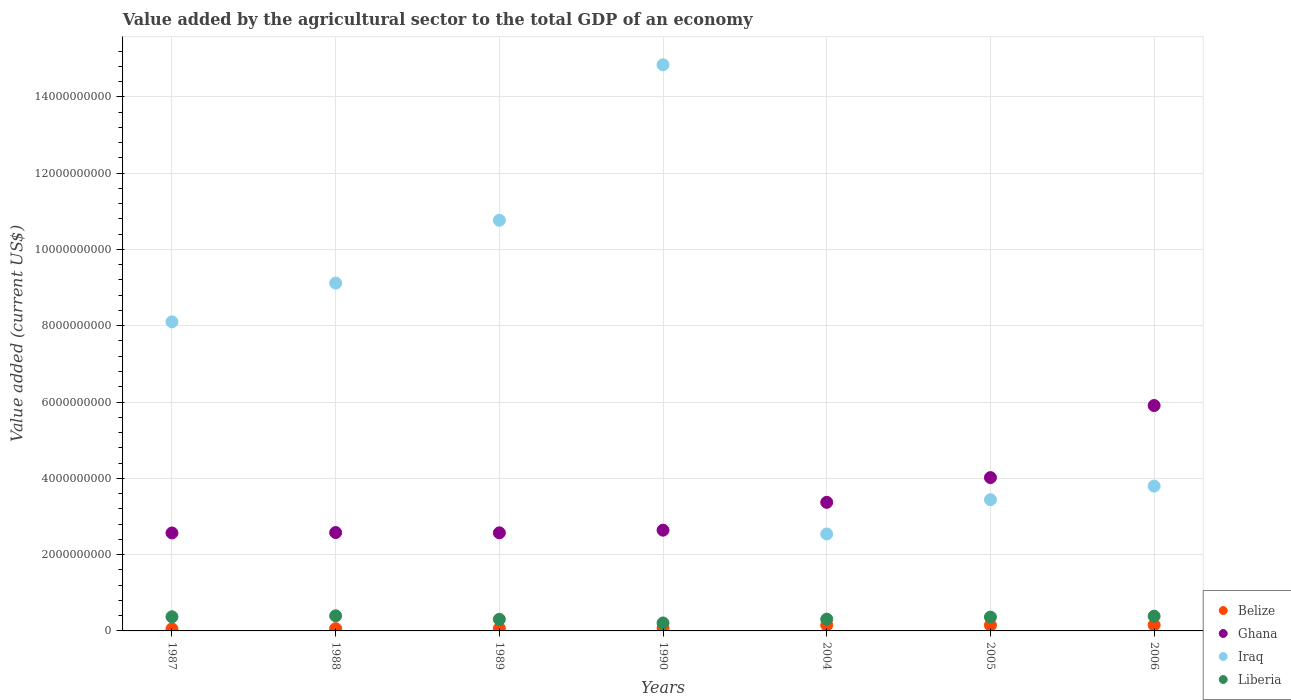What is the value added by the agricultural sector to the total GDP in Liberia in 2006?
Your answer should be compact. 3.85e+08. Across all years, what is the maximum value added by the agricultural sector to the total GDP in Iraq?
Give a very brief answer. 1.48e+1. Across all years, what is the minimum value added by the agricultural sector to the total GDP in Iraq?
Your answer should be compact. 2.54e+09. What is the total value added by the agricultural sector to the total GDP in Iraq in the graph?
Provide a succinct answer. 5.26e+1. What is the difference between the value added by the agricultural sector to the total GDP in Liberia in 1989 and that in 2006?
Provide a succinct answer. -8.10e+07. What is the difference between the value added by the agricultural sector to the total GDP in Belize in 2004 and the value added by the agricultural sector to the total GDP in Ghana in 1989?
Offer a terse response. -2.42e+09. What is the average value added by the agricultural sector to the total GDP in Belize per year?
Offer a very short reply. 1.01e+08. In the year 1987, what is the difference between the value added by the agricultural sector to the total GDP in Belize and value added by the agricultural sector to the total GDP in Ghana?
Make the answer very short. -2.51e+09. In how many years, is the value added by the agricultural sector to the total GDP in Iraq greater than 3200000000 US$?
Your answer should be very brief. 6. What is the ratio of the value added by the agricultural sector to the total GDP in Belize in 1987 to that in 1990?
Make the answer very short. 0.76. Is the value added by the agricultural sector to the total GDP in Ghana in 1987 less than that in 2005?
Make the answer very short. Yes. What is the difference between the highest and the second highest value added by the agricultural sector to the total GDP in Liberia?
Offer a very short reply. 1.02e+07. What is the difference between the highest and the lowest value added by the agricultural sector to the total GDP in Belize?
Give a very brief answer. 1.00e+08. In how many years, is the value added by the agricultural sector to the total GDP in Ghana greater than the average value added by the agricultural sector to the total GDP in Ghana taken over all years?
Your response must be concise. 2. Is the sum of the value added by the agricultural sector to the total GDP in Iraq in 1988 and 1990 greater than the maximum value added by the agricultural sector to the total GDP in Liberia across all years?
Your answer should be very brief. Yes. Is it the case that in every year, the sum of the value added by the agricultural sector to the total GDP in Belize and value added by the agricultural sector to the total GDP in Liberia  is greater than the value added by the agricultural sector to the total GDP in Ghana?
Give a very brief answer. No. Is the value added by the agricultural sector to the total GDP in Liberia strictly greater than the value added by the agricultural sector to the total GDP in Ghana over the years?
Offer a terse response. No. How many dotlines are there?
Make the answer very short. 4. How many years are there in the graph?
Ensure brevity in your answer.  7. What is the difference between two consecutive major ticks on the Y-axis?
Offer a very short reply. 2.00e+09. Are the values on the major ticks of Y-axis written in scientific E-notation?
Keep it short and to the point. No. Does the graph contain any zero values?
Offer a very short reply. No. Does the graph contain grids?
Keep it short and to the point. Yes. What is the title of the graph?
Your response must be concise. Value added by the agricultural sector to the total GDP of an economy. What is the label or title of the Y-axis?
Provide a short and direct response. Value added (current US$). What is the Value added (current US$) in Belize in 1987?
Make the answer very short. 5.45e+07. What is the Value added (current US$) of Ghana in 1987?
Keep it short and to the point. 2.57e+09. What is the Value added (current US$) of Iraq in 1987?
Provide a short and direct response. 8.10e+09. What is the Value added (current US$) of Liberia in 1987?
Offer a terse response. 3.71e+08. What is the Value added (current US$) in Belize in 1988?
Your answer should be very brief. 5.92e+07. What is the Value added (current US$) of Ghana in 1988?
Provide a short and direct response. 2.58e+09. What is the Value added (current US$) in Iraq in 1988?
Your answer should be compact. 9.12e+09. What is the Value added (current US$) of Liberia in 1988?
Provide a succinct answer. 3.96e+08. What is the Value added (current US$) of Belize in 1989?
Make the answer very short. 6.56e+07. What is the Value added (current US$) in Ghana in 1989?
Keep it short and to the point. 2.57e+09. What is the Value added (current US$) in Iraq in 1989?
Your response must be concise. 1.08e+1. What is the Value added (current US$) of Liberia in 1989?
Your response must be concise. 3.04e+08. What is the Value added (current US$) of Belize in 1990?
Your answer should be very brief. 7.18e+07. What is the Value added (current US$) in Ghana in 1990?
Offer a terse response. 2.64e+09. What is the Value added (current US$) of Iraq in 1990?
Provide a short and direct response. 1.48e+1. What is the Value added (current US$) in Liberia in 1990?
Offer a very short reply. 2.09e+08. What is the Value added (current US$) in Belize in 2004?
Your response must be concise. 1.52e+08. What is the Value added (current US$) of Ghana in 2004?
Offer a very short reply. 3.37e+09. What is the Value added (current US$) in Iraq in 2004?
Give a very brief answer. 2.54e+09. What is the Value added (current US$) of Liberia in 2004?
Make the answer very short. 3.09e+08. What is the Value added (current US$) in Belize in 2005?
Make the answer very short. 1.48e+08. What is the Value added (current US$) in Ghana in 2005?
Provide a succinct answer. 4.02e+09. What is the Value added (current US$) in Iraq in 2005?
Make the answer very short. 3.44e+09. What is the Value added (current US$) of Liberia in 2005?
Ensure brevity in your answer.  3.63e+08. What is the Value added (current US$) in Belize in 2006?
Provide a succinct answer. 1.55e+08. What is the Value added (current US$) in Ghana in 2006?
Make the answer very short. 5.91e+09. What is the Value added (current US$) of Iraq in 2006?
Offer a terse response. 3.80e+09. What is the Value added (current US$) in Liberia in 2006?
Provide a short and direct response. 3.85e+08. Across all years, what is the maximum Value added (current US$) of Belize?
Ensure brevity in your answer.  1.55e+08. Across all years, what is the maximum Value added (current US$) of Ghana?
Make the answer very short. 5.91e+09. Across all years, what is the maximum Value added (current US$) of Iraq?
Ensure brevity in your answer.  1.48e+1. Across all years, what is the maximum Value added (current US$) of Liberia?
Ensure brevity in your answer.  3.96e+08. Across all years, what is the minimum Value added (current US$) of Belize?
Offer a terse response. 5.45e+07. Across all years, what is the minimum Value added (current US$) of Ghana?
Your response must be concise. 2.57e+09. Across all years, what is the minimum Value added (current US$) in Iraq?
Make the answer very short. 2.54e+09. Across all years, what is the minimum Value added (current US$) of Liberia?
Keep it short and to the point. 2.09e+08. What is the total Value added (current US$) of Belize in the graph?
Make the answer very short. 7.06e+08. What is the total Value added (current US$) of Ghana in the graph?
Offer a terse response. 2.37e+1. What is the total Value added (current US$) of Iraq in the graph?
Offer a terse response. 5.26e+1. What is the total Value added (current US$) in Liberia in the graph?
Offer a very short reply. 2.34e+09. What is the difference between the Value added (current US$) of Belize in 1987 and that in 1988?
Your answer should be compact. -4.70e+06. What is the difference between the Value added (current US$) of Ghana in 1987 and that in 1988?
Offer a very short reply. -1.09e+07. What is the difference between the Value added (current US$) of Iraq in 1987 and that in 1988?
Your response must be concise. -1.02e+09. What is the difference between the Value added (current US$) in Liberia in 1987 and that in 1988?
Offer a very short reply. -2.48e+07. What is the difference between the Value added (current US$) of Belize in 1987 and that in 1989?
Your answer should be compact. -1.12e+07. What is the difference between the Value added (current US$) of Ghana in 1987 and that in 1989?
Keep it short and to the point. -3.77e+06. What is the difference between the Value added (current US$) of Iraq in 1987 and that in 1989?
Offer a terse response. -2.66e+09. What is the difference between the Value added (current US$) in Liberia in 1987 and that in 1989?
Provide a short and direct response. 6.64e+07. What is the difference between the Value added (current US$) of Belize in 1987 and that in 1990?
Your response must be concise. -1.72e+07. What is the difference between the Value added (current US$) of Ghana in 1987 and that in 1990?
Your answer should be very brief. -7.33e+07. What is the difference between the Value added (current US$) of Iraq in 1987 and that in 1990?
Your answer should be compact. -6.74e+09. What is the difference between the Value added (current US$) of Liberia in 1987 and that in 1990?
Ensure brevity in your answer.  1.62e+08. What is the difference between the Value added (current US$) of Belize in 1987 and that in 2004?
Your answer should be compact. -9.71e+07. What is the difference between the Value added (current US$) in Ghana in 1987 and that in 2004?
Your answer should be very brief. -8.03e+08. What is the difference between the Value added (current US$) in Iraq in 1987 and that in 2004?
Provide a succinct answer. 5.56e+09. What is the difference between the Value added (current US$) in Liberia in 1987 and that in 2004?
Keep it short and to the point. 6.21e+07. What is the difference between the Value added (current US$) in Belize in 1987 and that in 2005?
Offer a very short reply. -9.38e+07. What is the difference between the Value added (current US$) in Ghana in 1987 and that in 2005?
Make the answer very short. -1.45e+09. What is the difference between the Value added (current US$) in Iraq in 1987 and that in 2005?
Offer a very short reply. 4.66e+09. What is the difference between the Value added (current US$) of Liberia in 1987 and that in 2005?
Make the answer very short. 7.72e+06. What is the difference between the Value added (current US$) of Belize in 1987 and that in 2006?
Your answer should be compact. -1.00e+08. What is the difference between the Value added (current US$) in Ghana in 1987 and that in 2006?
Provide a succinct answer. -3.34e+09. What is the difference between the Value added (current US$) in Iraq in 1987 and that in 2006?
Your response must be concise. 4.31e+09. What is the difference between the Value added (current US$) in Liberia in 1987 and that in 2006?
Give a very brief answer. -1.46e+07. What is the difference between the Value added (current US$) of Belize in 1988 and that in 1989?
Provide a short and direct response. -6.45e+06. What is the difference between the Value added (current US$) of Ghana in 1988 and that in 1989?
Offer a terse response. 7.15e+06. What is the difference between the Value added (current US$) in Iraq in 1988 and that in 1989?
Offer a terse response. -1.65e+09. What is the difference between the Value added (current US$) of Liberia in 1988 and that in 1989?
Offer a very short reply. 9.12e+07. What is the difference between the Value added (current US$) of Belize in 1988 and that in 1990?
Your answer should be compact. -1.26e+07. What is the difference between the Value added (current US$) in Ghana in 1988 and that in 1990?
Keep it short and to the point. -6.23e+07. What is the difference between the Value added (current US$) in Iraq in 1988 and that in 1990?
Your response must be concise. -5.72e+09. What is the difference between the Value added (current US$) of Liberia in 1988 and that in 1990?
Provide a short and direct response. 1.87e+08. What is the difference between the Value added (current US$) of Belize in 1988 and that in 2004?
Ensure brevity in your answer.  -9.24e+07. What is the difference between the Value added (current US$) in Ghana in 1988 and that in 2004?
Ensure brevity in your answer.  -7.92e+08. What is the difference between the Value added (current US$) in Iraq in 1988 and that in 2004?
Offer a very short reply. 6.58e+09. What is the difference between the Value added (current US$) in Liberia in 1988 and that in 2004?
Give a very brief answer. 8.69e+07. What is the difference between the Value added (current US$) of Belize in 1988 and that in 2005?
Provide a succinct answer. -8.91e+07. What is the difference between the Value added (current US$) in Ghana in 1988 and that in 2005?
Give a very brief answer. -1.44e+09. What is the difference between the Value added (current US$) in Iraq in 1988 and that in 2005?
Provide a short and direct response. 5.68e+09. What is the difference between the Value added (current US$) of Liberia in 1988 and that in 2005?
Offer a very short reply. 3.25e+07. What is the difference between the Value added (current US$) in Belize in 1988 and that in 2006?
Provide a short and direct response. -9.57e+07. What is the difference between the Value added (current US$) in Ghana in 1988 and that in 2006?
Offer a very short reply. -3.33e+09. What is the difference between the Value added (current US$) of Iraq in 1988 and that in 2006?
Provide a short and direct response. 5.32e+09. What is the difference between the Value added (current US$) in Liberia in 1988 and that in 2006?
Your response must be concise. 1.02e+07. What is the difference between the Value added (current US$) in Belize in 1989 and that in 1990?
Make the answer very short. -6.10e+06. What is the difference between the Value added (current US$) in Ghana in 1989 and that in 1990?
Give a very brief answer. -6.95e+07. What is the difference between the Value added (current US$) in Iraq in 1989 and that in 1990?
Give a very brief answer. -4.08e+09. What is the difference between the Value added (current US$) in Liberia in 1989 and that in 1990?
Your answer should be very brief. 9.55e+07. What is the difference between the Value added (current US$) of Belize in 1989 and that in 2004?
Ensure brevity in your answer.  -8.60e+07. What is the difference between the Value added (current US$) in Ghana in 1989 and that in 2004?
Provide a short and direct response. -7.99e+08. What is the difference between the Value added (current US$) of Iraq in 1989 and that in 2004?
Keep it short and to the point. 8.22e+09. What is the difference between the Value added (current US$) of Liberia in 1989 and that in 2004?
Give a very brief answer. -4.28e+06. What is the difference between the Value added (current US$) of Belize in 1989 and that in 2005?
Keep it short and to the point. -8.26e+07. What is the difference between the Value added (current US$) of Ghana in 1989 and that in 2005?
Offer a terse response. -1.45e+09. What is the difference between the Value added (current US$) of Iraq in 1989 and that in 2005?
Your answer should be very brief. 7.32e+09. What is the difference between the Value added (current US$) of Liberia in 1989 and that in 2005?
Offer a terse response. -5.87e+07. What is the difference between the Value added (current US$) of Belize in 1989 and that in 2006?
Provide a short and direct response. -8.93e+07. What is the difference between the Value added (current US$) of Ghana in 1989 and that in 2006?
Your answer should be compact. -3.34e+09. What is the difference between the Value added (current US$) in Iraq in 1989 and that in 2006?
Provide a succinct answer. 6.97e+09. What is the difference between the Value added (current US$) of Liberia in 1989 and that in 2006?
Provide a succinct answer. -8.10e+07. What is the difference between the Value added (current US$) in Belize in 1990 and that in 2004?
Provide a short and direct response. -7.99e+07. What is the difference between the Value added (current US$) of Ghana in 1990 and that in 2004?
Keep it short and to the point. -7.30e+08. What is the difference between the Value added (current US$) in Iraq in 1990 and that in 2004?
Provide a short and direct response. 1.23e+1. What is the difference between the Value added (current US$) of Liberia in 1990 and that in 2004?
Your answer should be very brief. -9.98e+07. What is the difference between the Value added (current US$) of Belize in 1990 and that in 2005?
Your answer should be compact. -7.65e+07. What is the difference between the Value added (current US$) in Ghana in 1990 and that in 2005?
Provide a short and direct response. -1.38e+09. What is the difference between the Value added (current US$) in Iraq in 1990 and that in 2005?
Keep it short and to the point. 1.14e+1. What is the difference between the Value added (current US$) in Liberia in 1990 and that in 2005?
Your answer should be very brief. -1.54e+08. What is the difference between the Value added (current US$) in Belize in 1990 and that in 2006?
Your answer should be compact. -8.32e+07. What is the difference between the Value added (current US$) of Ghana in 1990 and that in 2006?
Make the answer very short. -3.27e+09. What is the difference between the Value added (current US$) of Iraq in 1990 and that in 2006?
Offer a very short reply. 1.10e+1. What is the difference between the Value added (current US$) in Liberia in 1990 and that in 2006?
Offer a very short reply. -1.76e+08. What is the difference between the Value added (current US$) of Belize in 2004 and that in 2005?
Provide a short and direct response. 3.34e+06. What is the difference between the Value added (current US$) of Ghana in 2004 and that in 2005?
Offer a terse response. -6.49e+08. What is the difference between the Value added (current US$) of Iraq in 2004 and that in 2005?
Make the answer very short. -8.99e+08. What is the difference between the Value added (current US$) of Liberia in 2004 and that in 2005?
Give a very brief answer. -5.44e+07. What is the difference between the Value added (current US$) in Belize in 2004 and that in 2006?
Offer a terse response. -3.29e+06. What is the difference between the Value added (current US$) of Ghana in 2004 and that in 2006?
Give a very brief answer. -2.54e+09. What is the difference between the Value added (current US$) in Iraq in 2004 and that in 2006?
Make the answer very short. -1.25e+09. What is the difference between the Value added (current US$) in Liberia in 2004 and that in 2006?
Offer a terse response. -7.67e+07. What is the difference between the Value added (current US$) of Belize in 2005 and that in 2006?
Your answer should be very brief. -6.64e+06. What is the difference between the Value added (current US$) in Ghana in 2005 and that in 2006?
Keep it short and to the point. -1.89e+09. What is the difference between the Value added (current US$) of Iraq in 2005 and that in 2006?
Make the answer very short. -3.55e+08. What is the difference between the Value added (current US$) in Liberia in 2005 and that in 2006?
Ensure brevity in your answer.  -2.23e+07. What is the difference between the Value added (current US$) of Belize in 1987 and the Value added (current US$) of Ghana in 1988?
Ensure brevity in your answer.  -2.52e+09. What is the difference between the Value added (current US$) of Belize in 1987 and the Value added (current US$) of Iraq in 1988?
Provide a short and direct response. -9.06e+09. What is the difference between the Value added (current US$) of Belize in 1987 and the Value added (current US$) of Liberia in 1988?
Make the answer very short. -3.41e+08. What is the difference between the Value added (current US$) in Ghana in 1987 and the Value added (current US$) in Iraq in 1988?
Your answer should be compact. -6.55e+09. What is the difference between the Value added (current US$) in Ghana in 1987 and the Value added (current US$) in Liberia in 1988?
Your answer should be compact. 2.17e+09. What is the difference between the Value added (current US$) of Iraq in 1987 and the Value added (current US$) of Liberia in 1988?
Your answer should be compact. 7.71e+09. What is the difference between the Value added (current US$) in Belize in 1987 and the Value added (current US$) in Ghana in 1989?
Give a very brief answer. -2.52e+09. What is the difference between the Value added (current US$) in Belize in 1987 and the Value added (current US$) in Iraq in 1989?
Your answer should be compact. -1.07e+1. What is the difference between the Value added (current US$) in Belize in 1987 and the Value added (current US$) in Liberia in 1989?
Offer a very short reply. -2.50e+08. What is the difference between the Value added (current US$) in Ghana in 1987 and the Value added (current US$) in Iraq in 1989?
Ensure brevity in your answer.  -8.20e+09. What is the difference between the Value added (current US$) of Ghana in 1987 and the Value added (current US$) of Liberia in 1989?
Keep it short and to the point. 2.26e+09. What is the difference between the Value added (current US$) of Iraq in 1987 and the Value added (current US$) of Liberia in 1989?
Offer a very short reply. 7.80e+09. What is the difference between the Value added (current US$) in Belize in 1987 and the Value added (current US$) in Ghana in 1990?
Your response must be concise. -2.59e+09. What is the difference between the Value added (current US$) in Belize in 1987 and the Value added (current US$) in Iraq in 1990?
Offer a very short reply. -1.48e+1. What is the difference between the Value added (current US$) in Belize in 1987 and the Value added (current US$) in Liberia in 1990?
Your response must be concise. -1.54e+08. What is the difference between the Value added (current US$) of Ghana in 1987 and the Value added (current US$) of Iraq in 1990?
Make the answer very short. -1.23e+1. What is the difference between the Value added (current US$) of Ghana in 1987 and the Value added (current US$) of Liberia in 1990?
Keep it short and to the point. 2.36e+09. What is the difference between the Value added (current US$) of Iraq in 1987 and the Value added (current US$) of Liberia in 1990?
Provide a succinct answer. 7.89e+09. What is the difference between the Value added (current US$) of Belize in 1987 and the Value added (current US$) of Ghana in 2004?
Ensure brevity in your answer.  -3.32e+09. What is the difference between the Value added (current US$) of Belize in 1987 and the Value added (current US$) of Iraq in 2004?
Your response must be concise. -2.49e+09. What is the difference between the Value added (current US$) of Belize in 1987 and the Value added (current US$) of Liberia in 2004?
Keep it short and to the point. -2.54e+08. What is the difference between the Value added (current US$) in Ghana in 1987 and the Value added (current US$) in Iraq in 2004?
Offer a terse response. 2.64e+07. What is the difference between the Value added (current US$) of Ghana in 1987 and the Value added (current US$) of Liberia in 2004?
Ensure brevity in your answer.  2.26e+09. What is the difference between the Value added (current US$) in Iraq in 1987 and the Value added (current US$) in Liberia in 2004?
Your response must be concise. 7.79e+09. What is the difference between the Value added (current US$) in Belize in 1987 and the Value added (current US$) in Ghana in 2005?
Keep it short and to the point. -3.96e+09. What is the difference between the Value added (current US$) in Belize in 1987 and the Value added (current US$) in Iraq in 2005?
Your answer should be compact. -3.39e+09. What is the difference between the Value added (current US$) in Belize in 1987 and the Value added (current US$) in Liberia in 2005?
Keep it short and to the point. -3.09e+08. What is the difference between the Value added (current US$) of Ghana in 1987 and the Value added (current US$) of Iraq in 2005?
Offer a terse response. -8.72e+08. What is the difference between the Value added (current US$) of Ghana in 1987 and the Value added (current US$) of Liberia in 2005?
Offer a very short reply. 2.20e+09. What is the difference between the Value added (current US$) of Iraq in 1987 and the Value added (current US$) of Liberia in 2005?
Keep it short and to the point. 7.74e+09. What is the difference between the Value added (current US$) of Belize in 1987 and the Value added (current US$) of Ghana in 2006?
Offer a terse response. -5.85e+09. What is the difference between the Value added (current US$) in Belize in 1987 and the Value added (current US$) in Iraq in 2006?
Your answer should be compact. -3.74e+09. What is the difference between the Value added (current US$) of Belize in 1987 and the Value added (current US$) of Liberia in 2006?
Your answer should be compact. -3.31e+08. What is the difference between the Value added (current US$) of Ghana in 1987 and the Value added (current US$) of Iraq in 2006?
Make the answer very short. -1.23e+09. What is the difference between the Value added (current US$) of Ghana in 1987 and the Value added (current US$) of Liberia in 2006?
Offer a terse response. 2.18e+09. What is the difference between the Value added (current US$) of Iraq in 1987 and the Value added (current US$) of Liberia in 2006?
Provide a short and direct response. 7.72e+09. What is the difference between the Value added (current US$) of Belize in 1988 and the Value added (current US$) of Ghana in 1989?
Ensure brevity in your answer.  -2.51e+09. What is the difference between the Value added (current US$) of Belize in 1988 and the Value added (current US$) of Iraq in 1989?
Ensure brevity in your answer.  -1.07e+1. What is the difference between the Value added (current US$) of Belize in 1988 and the Value added (current US$) of Liberia in 1989?
Your answer should be very brief. -2.45e+08. What is the difference between the Value added (current US$) of Ghana in 1988 and the Value added (current US$) of Iraq in 1989?
Offer a very short reply. -8.19e+09. What is the difference between the Value added (current US$) of Ghana in 1988 and the Value added (current US$) of Liberia in 1989?
Your answer should be compact. 2.27e+09. What is the difference between the Value added (current US$) of Iraq in 1988 and the Value added (current US$) of Liberia in 1989?
Provide a short and direct response. 8.81e+09. What is the difference between the Value added (current US$) of Belize in 1988 and the Value added (current US$) of Ghana in 1990?
Provide a short and direct response. -2.58e+09. What is the difference between the Value added (current US$) in Belize in 1988 and the Value added (current US$) in Iraq in 1990?
Provide a succinct answer. -1.48e+1. What is the difference between the Value added (current US$) of Belize in 1988 and the Value added (current US$) of Liberia in 1990?
Your answer should be compact. -1.50e+08. What is the difference between the Value added (current US$) of Ghana in 1988 and the Value added (current US$) of Iraq in 1990?
Keep it short and to the point. -1.23e+1. What is the difference between the Value added (current US$) of Ghana in 1988 and the Value added (current US$) of Liberia in 1990?
Give a very brief answer. 2.37e+09. What is the difference between the Value added (current US$) in Iraq in 1988 and the Value added (current US$) in Liberia in 1990?
Provide a short and direct response. 8.91e+09. What is the difference between the Value added (current US$) of Belize in 1988 and the Value added (current US$) of Ghana in 2004?
Make the answer very short. -3.31e+09. What is the difference between the Value added (current US$) in Belize in 1988 and the Value added (current US$) in Iraq in 2004?
Keep it short and to the point. -2.48e+09. What is the difference between the Value added (current US$) of Belize in 1988 and the Value added (current US$) of Liberia in 2004?
Your answer should be compact. -2.50e+08. What is the difference between the Value added (current US$) of Ghana in 1988 and the Value added (current US$) of Iraq in 2004?
Offer a terse response. 3.74e+07. What is the difference between the Value added (current US$) of Ghana in 1988 and the Value added (current US$) of Liberia in 2004?
Your answer should be very brief. 2.27e+09. What is the difference between the Value added (current US$) of Iraq in 1988 and the Value added (current US$) of Liberia in 2004?
Ensure brevity in your answer.  8.81e+09. What is the difference between the Value added (current US$) in Belize in 1988 and the Value added (current US$) in Ghana in 2005?
Give a very brief answer. -3.96e+09. What is the difference between the Value added (current US$) in Belize in 1988 and the Value added (current US$) in Iraq in 2005?
Your answer should be compact. -3.38e+09. What is the difference between the Value added (current US$) in Belize in 1988 and the Value added (current US$) in Liberia in 2005?
Provide a short and direct response. -3.04e+08. What is the difference between the Value added (current US$) in Ghana in 1988 and the Value added (current US$) in Iraq in 2005?
Your answer should be very brief. -8.62e+08. What is the difference between the Value added (current US$) in Ghana in 1988 and the Value added (current US$) in Liberia in 2005?
Your answer should be very brief. 2.22e+09. What is the difference between the Value added (current US$) of Iraq in 1988 and the Value added (current US$) of Liberia in 2005?
Offer a very short reply. 8.75e+09. What is the difference between the Value added (current US$) in Belize in 1988 and the Value added (current US$) in Ghana in 2006?
Keep it short and to the point. -5.85e+09. What is the difference between the Value added (current US$) in Belize in 1988 and the Value added (current US$) in Iraq in 2006?
Your answer should be compact. -3.74e+09. What is the difference between the Value added (current US$) of Belize in 1988 and the Value added (current US$) of Liberia in 2006?
Ensure brevity in your answer.  -3.26e+08. What is the difference between the Value added (current US$) in Ghana in 1988 and the Value added (current US$) in Iraq in 2006?
Offer a very short reply. -1.22e+09. What is the difference between the Value added (current US$) in Ghana in 1988 and the Value added (current US$) in Liberia in 2006?
Make the answer very short. 2.19e+09. What is the difference between the Value added (current US$) of Iraq in 1988 and the Value added (current US$) of Liberia in 2006?
Offer a very short reply. 8.73e+09. What is the difference between the Value added (current US$) in Belize in 1989 and the Value added (current US$) in Ghana in 1990?
Keep it short and to the point. -2.58e+09. What is the difference between the Value added (current US$) of Belize in 1989 and the Value added (current US$) of Iraq in 1990?
Provide a short and direct response. -1.48e+1. What is the difference between the Value added (current US$) in Belize in 1989 and the Value added (current US$) in Liberia in 1990?
Your response must be concise. -1.43e+08. What is the difference between the Value added (current US$) of Ghana in 1989 and the Value added (current US$) of Iraq in 1990?
Provide a succinct answer. -1.23e+1. What is the difference between the Value added (current US$) in Ghana in 1989 and the Value added (current US$) in Liberia in 1990?
Make the answer very short. 2.36e+09. What is the difference between the Value added (current US$) of Iraq in 1989 and the Value added (current US$) of Liberia in 1990?
Give a very brief answer. 1.06e+1. What is the difference between the Value added (current US$) in Belize in 1989 and the Value added (current US$) in Ghana in 2004?
Provide a short and direct response. -3.31e+09. What is the difference between the Value added (current US$) in Belize in 1989 and the Value added (current US$) in Iraq in 2004?
Your response must be concise. -2.48e+09. What is the difference between the Value added (current US$) in Belize in 1989 and the Value added (current US$) in Liberia in 2004?
Give a very brief answer. -2.43e+08. What is the difference between the Value added (current US$) in Ghana in 1989 and the Value added (current US$) in Iraq in 2004?
Make the answer very short. 3.02e+07. What is the difference between the Value added (current US$) of Ghana in 1989 and the Value added (current US$) of Liberia in 2004?
Ensure brevity in your answer.  2.26e+09. What is the difference between the Value added (current US$) in Iraq in 1989 and the Value added (current US$) in Liberia in 2004?
Ensure brevity in your answer.  1.05e+1. What is the difference between the Value added (current US$) of Belize in 1989 and the Value added (current US$) of Ghana in 2005?
Keep it short and to the point. -3.95e+09. What is the difference between the Value added (current US$) of Belize in 1989 and the Value added (current US$) of Iraq in 2005?
Keep it short and to the point. -3.37e+09. What is the difference between the Value added (current US$) of Belize in 1989 and the Value added (current US$) of Liberia in 2005?
Make the answer very short. -2.98e+08. What is the difference between the Value added (current US$) of Ghana in 1989 and the Value added (current US$) of Iraq in 2005?
Keep it short and to the point. -8.69e+08. What is the difference between the Value added (current US$) in Ghana in 1989 and the Value added (current US$) in Liberia in 2005?
Provide a succinct answer. 2.21e+09. What is the difference between the Value added (current US$) of Iraq in 1989 and the Value added (current US$) of Liberia in 2005?
Offer a terse response. 1.04e+1. What is the difference between the Value added (current US$) of Belize in 1989 and the Value added (current US$) of Ghana in 2006?
Offer a terse response. -5.84e+09. What is the difference between the Value added (current US$) in Belize in 1989 and the Value added (current US$) in Iraq in 2006?
Your response must be concise. -3.73e+09. What is the difference between the Value added (current US$) in Belize in 1989 and the Value added (current US$) in Liberia in 2006?
Your answer should be very brief. -3.20e+08. What is the difference between the Value added (current US$) in Ghana in 1989 and the Value added (current US$) in Iraq in 2006?
Offer a terse response. -1.22e+09. What is the difference between the Value added (current US$) of Ghana in 1989 and the Value added (current US$) of Liberia in 2006?
Keep it short and to the point. 2.19e+09. What is the difference between the Value added (current US$) in Iraq in 1989 and the Value added (current US$) in Liberia in 2006?
Offer a terse response. 1.04e+1. What is the difference between the Value added (current US$) of Belize in 1990 and the Value added (current US$) of Ghana in 2004?
Offer a very short reply. -3.30e+09. What is the difference between the Value added (current US$) of Belize in 1990 and the Value added (current US$) of Iraq in 2004?
Your response must be concise. -2.47e+09. What is the difference between the Value added (current US$) of Belize in 1990 and the Value added (current US$) of Liberia in 2004?
Ensure brevity in your answer.  -2.37e+08. What is the difference between the Value added (current US$) of Ghana in 1990 and the Value added (current US$) of Iraq in 2004?
Your answer should be very brief. 9.97e+07. What is the difference between the Value added (current US$) in Ghana in 1990 and the Value added (current US$) in Liberia in 2004?
Make the answer very short. 2.33e+09. What is the difference between the Value added (current US$) in Iraq in 1990 and the Value added (current US$) in Liberia in 2004?
Ensure brevity in your answer.  1.45e+1. What is the difference between the Value added (current US$) in Belize in 1990 and the Value added (current US$) in Ghana in 2005?
Offer a terse response. -3.95e+09. What is the difference between the Value added (current US$) in Belize in 1990 and the Value added (current US$) in Iraq in 2005?
Your answer should be compact. -3.37e+09. What is the difference between the Value added (current US$) in Belize in 1990 and the Value added (current US$) in Liberia in 2005?
Keep it short and to the point. -2.91e+08. What is the difference between the Value added (current US$) of Ghana in 1990 and the Value added (current US$) of Iraq in 2005?
Ensure brevity in your answer.  -7.99e+08. What is the difference between the Value added (current US$) of Ghana in 1990 and the Value added (current US$) of Liberia in 2005?
Your answer should be compact. 2.28e+09. What is the difference between the Value added (current US$) in Iraq in 1990 and the Value added (current US$) in Liberia in 2005?
Offer a very short reply. 1.45e+1. What is the difference between the Value added (current US$) of Belize in 1990 and the Value added (current US$) of Ghana in 2006?
Your answer should be compact. -5.84e+09. What is the difference between the Value added (current US$) of Belize in 1990 and the Value added (current US$) of Iraq in 2006?
Your response must be concise. -3.72e+09. What is the difference between the Value added (current US$) of Belize in 1990 and the Value added (current US$) of Liberia in 2006?
Offer a terse response. -3.14e+08. What is the difference between the Value added (current US$) in Ghana in 1990 and the Value added (current US$) in Iraq in 2006?
Your response must be concise. -1.15e+09. What is the difference between the Value added (current US$) in Ghana in 1990 and the Value added (current US$) in Liberia in 2006?
Your answer should be compact. 2.26e+09. What is the difference between the Value added (current US$) in Iraq in 1990 and the Value added (current US$) in Liberia in 2006?
Ensure brevity in your answer.  1.45e+1. What is the difference between the Value added (current US$) of Belize in 2004 and the Value added (current US$) of Ghana in 2005?
Provide a succinct answer. -3.87e+09. What is the difference between the Value added (current US$) of Belize in 2004 and the Value added (current US$) of Iraq in 2005?
Give a very brief answer. -3.29e+09. What is the difference between the Value added (current US$) of Belize in 2004 and the Value added (current US$) of Liberia in 2005?
Your answer should be compact. -2.12e+08. What is the difference between the Value added (current US$) in Ghana in 2004 and the Value added (current US$) in Iraq in 2005?
Offer a very short reply. -6.96e+07. What is the difference between the Value added (current US$) in Ghana in 2004 and the Value added (current US$) in Liberia in 2005?
Provide a succinct answer. 3.01e+09. What is the difference between the Value added (current US$) in Iraq in 2004 and the Value added (current US$) in Liberia in 2005?
Ensure brevity in your answer.  2.18e+09. What is the difference between the Value added (current US$) in Belize in 2004 and the Value added (current US$) in Ghana in 2006?
Your answer should be very brief. -5.76e+09. What is the difference between the Value added (current US$) in Belize in 2004 and the Value added (current US$) in Iraq in 2006?
Make the answer very short. -3.64e+09. What is the difference between the Value added (current US$) of Belize in 2004 and the Value added (current US$) of Liberia in 2006?
Offer a terse response. -2.34e+08. What is the difference between the Value added (current US$) in Ghana in 2004 and the Value added (current US$) in Iraq in 2006?
Provide a succinct answer. -4.24e+08. What is the difference between the Value added (current US$) in Ghana in 2004 and the Value added (current US$) in Liberia in 2006?
Give a very brief answer. 2.99e+09. What is the difference between the Value added (current US$) of Iraq in 2004 and the Value added (current US$) of Liberia in 2006?
Give a very brief answer. 2.16e+09. What is the difference between the Value added (current US$) in Belize in 2005 and the Value added (current US$) in Ghana in 2006?
Ensure brevity in your answer.  -5.76e+09. What is the difference between the Value added (current US$) of Belize in 2005 and the Value added (current US$) of Iraq in 2006?
Ensure brevity in your answer.  -3.65e+09. What is the difference between the Value added (current US$) of Belize in 2005 and the Value added (current US$) of Liberia in 2006?
Your answer should be compact. -2.37e+08. What is the difference between the Value added (current US$) of Ghana in 2005 and the Value added (current US$) of Iraq in 2006?
Give a very brief answer. 2.24e+08. What is the difference between the Value added (current US$) of Ghana in 2005 and the Value added (current US$) of Liberia in 2006?
Give a very brief answer. 3.63e+09. What is the difference between the Value added (current US$) in Iraq in 2005 and the Value added (current US$) in Liberia in 2006?
Make the answer very short. 3.05e+09. What is the average Value added (current US$) in Belize per year?
Your response must be concise. 1.01e+08. What is the average Value added (current US$) of Ghana per year?
Give a very brief answer. 3.38e+09. What is the average Value added (current US$) of Iraq per year?
Offer a terse response. 7.51e+09. What is the average Value added (current US$) of Liberia per year?
Your answer should be compact. 3.34e+08. In the year 1987, what is the difference between the Value added (current US$) of Belize and Value added (current US$) of Ghana?
Provide a succinct answer. -2.51e+09. In the year 1987, what is the difference between the Value added (current US$) of Belize and Value added (current US$) of Iraq?
Offer a very short reply. -8.05e+09. In the year 1987, what is the difference between the Value added (current US$) of Belize and Value added (current US$) of Liberia?
Keep it short and to the point. -3.16e+08. In the year 1987, what is the difference between the Value added (current US$) of Ghana and Value added (current US$) of Iraq?
Make the answer very short. -5.53e+09. In the year 1987, what is the difference between the Value added (current US$) in Ghana and Value added (current US$) in Liberia?
Provide a succinct answer. 2.20e+09. In the year 1987, what is the difference between the Value added (current US$) of Iraq and Value added (current US$) of Liberia?
Your answer should be very brief. 7.73e+09. In the year 1988, what is the difference between the Value added (current US$) of Belize and Value added (current US$) of Ghana?
Offer a very short reply. -2.52e+09. In the year 1988, what is the difference between the Value added (current US$) in Belize and Value added (current US$) in Iraq?
Provide a short and direct response. -9.06e+09. In the year 1988, what is the difference between the Value added (current US$) of Belize and Value added (current US$) of Liberia?
Ensure brevity in your answer.  -3.36e+08. In the year 1988, what is the difference between the Value added (current US$) in Ghana and Value added (current US$) in Iraq?
Provide a succinct answer. -6.54e+09. In the year 1988, what is the difference between the Value added (current US$) in Ghana and Value added (current US$) in Liberia?
Keep it short and to the point. 2.18e+09. In the year 1988, what is the difference between the Value added (current US$) of Iraq and Value added (current US$) of Liberia?
Provide a short and direct response. 8.72e+09. In the year 1989, what is the difference between the Value added (current US$) of Belize and Value added (current US$) of Ghana?
Provide a short and direct response. -2.51e+09. In the year 1989, what is the difference between the Value added (current US$) in Belize and Value added (current US$) in Iraq?
Make the answer very short. -1.07e+1. In the year 1989, what is the difference between the Value added (current US$) in Belize and Value added (current US$) in Liberia?
Offer a terse response. -2.39e+08. In the year 1989, what is the difference between the Value added (current US$) of Ghana and Value added (current US$) of Iraq?
Offer a very short reply. -8.19e+09. In the year 1989, what is the difference between the Value added (current US$) of Ghana and Value added (current US$) of Liberia?
Your response must be concise. 2.27e+09. In the year 1989, what is the difference between the Value added (current US$) of Iraq and Value added (current US$) of Liberia?
Give a very brief answer. 1.05e+1. In the year 1990, what is the difference between the Value added (current US$) in Belize and Value added (current US$) in Ghana?
Offer a terse response. -2.57e+09. In the year 1990, what is the difference between the Value added (current US$) in Belize and Value added (current US$) in Iraq?
Keep it short and to the point. -1.48e+1. In the year 1990, what is the difference between the Value added (current US$) of Belize and Value added (current US$) of Liberia?
Your answer should be very brief. -1.37e+08. In the year 1990, what is the difference between the Value added (current US$) in Ghana and Value added (current US$) in Iraq?
Provide a succinct answer. -1.22e+1. In the year 1990, what is the difference between the Value added (current US$) in Ghana and Value added (current US$) in Liberia?
Your response must be concise. 2.43e+09. In the year 1990, what is the difference between the Value added (current US$) of Iraq and Value added (current US$) of Liberia?
Provide a short and direct response. 1.46e+1. In the year 2004, what is the difference between the Value added (current US$) of Belize and Value added (current US$) of Ghana?
Your response must be concise. -3.22e+09. In the year 2004, what is the difference between the Value added (current US$) of Belize and Value added (current US$) of Iraq?
Make the answer very short. -2.39e+09. In the year 2004, what is the difference between the Value added (current US$) in Belize and Value added (current US$) in Liberia?
Keep it short and to the point. -1.57e+08. In the year 2004, what is the difference between the Value added (current US$) in Ghana and Value added (current US$) in Iraq?
Make the answer very short. 8.29e+08. In the year 2004, what is the difference between the Value added (current US$) of Ghana and Value added (current US$) of Liberia?
Your response must be concise. 3.06e+09. In the year 2004, what is the difference between the Value added (current US$) of Iraq and Value added (current US$) of Liberia?
Ensure brevity in your answer.  2.23e+09. In the year 2005, what is the difference between the Value added (current US$) of Belize and Value added (current US$) of Ghana?
Your answer should be compact. -3.87e+09. In the year 2005, what is the difference between the Value added (current US$) in Belize and Value added (current US$) in Iraq?
Give a very brief answer. -3.29e+09. In the year 2005, what is the difference between the Value added (current US$) in Belize and Value added (current US$) in Liberia?
Your answer should be very brief. -2.15e+08. In the year 2005, what is the difference between the Value added (current US$) of Ghana and Value added (current US$) of Iraq?
Provide a short and direct response. 5.79e+08. In the year 2005, what is the difference between the Value added (current US$) in Ghana and Value added (current US$) in Liberia?
Provide a succinct answer. 3.66e+09. In the year 2005, what is the difference between the Value added (current US$) of Iraq and Value added (current US$) of Liberia?
Your answer should be very brief. 3.08e+09. In the year 2006, what is the difference between the Value added (current US$) in Belize and Value added (current US$) in Ghana?
Make the answer very short. -5.75e+09. In the year 2006, what is the difference between the Value added (current US$) of Belize and Value added (current US$) of Iraq?
Offer a very short reply. -3.64e+09. In the year 2006, what is the difference between the Value added (current US$) in Belize and Value added (current US$) in Liberia?
Give a very brief answer. -2.31e+08. In the year 2006, what is the difference between the Value added (current US$) in Ghana and Value added (current US$) in Iraq?
Keep it short and to the point. 2.11e+09. In the year 2006, what is the difference between the Value added (current US$) in Ghana and Value added (current US$) in Liberia?
Your answer should be compact. 5.52e+09. In the year 2006, what is the difference between the Value added (current US$) in Iraq and Value added (current US$) in Liberia?
Ensure brevity in your answer.  3.41e+09. What is the ratio of the Value added (current US$) in Belize in 1987 to that in 1988?
Your answer should be compact. 0.92. What is the ratio of the Value added (current US$) in Iraq in 1987 to that in 1988?
Offer a terse response. 0.89. What is the ratio of the Value added (current US$) of Liberia in 1987 to that in 1988?
Offer a very short reply. 0.94. What is the ratio of the Value added (current US$) of Belize in 1987 to that in 1989?
Offer a terse response. 0.83. What is the ratio of the Value added (current US$) in Iraq in 1987 to that in 1989?
Make the answer very short. 0.75. What is the ratio of the Value added (current US$) of Liberia in 1987 to that in 1989?
Make the answer very short. 1.22. What is the ratio of the Value added (current US$) in Belize in 1987 to that in 1990?
Provide a short and direct response. 0.76. What is the ratio of the Value added (current US$) of Ghana in 1987 to that in 1990?
Provide a succinct answer. 0.97. What is the ratio of the Value added (current US$) of Iraq in 1987 to that in 1990?
Make the answer very short. 0.55. What is the ratio of the Value added (current US$) in Liberia in 1987 to that in 1990?
Provide a succinct answer. 1.77. What is the ratio of the Value added (current US$) of Belize in 1987 to that in 2004?
Your response must be concise. 0.36. What is the ratio of the Value added (current US$) of Ghana in 1987 to that in 2004?
Provide a short and direct response. 0.76. What is the ratio of the Value added (current US$) of Iraq in 1987 to that in 2004?
Ensure brevity in your answer.  3.19. What is the ratio of the Value added (current US$) of Liberia in 1987 to that in 2004?
Your answer should be very brief. 1.2. What is the ratio of the Value added (current US$) in Belize in 1987 to that in 2005?
Your answer should be very brief. 0.37. What is the ratio of the Value added (current US$) in Ghana in 1987 to that in 2005?
Provide a short and direct response. 0.64. What is the ratio of the Value added (current US$) of Iraq in 1987 to that in 2005?
Keep it short and to the point. 2.36. What is the ratio of the Value added (current US$) in Liberia in 1987 to that in 2005?
Provide a short and direct response. 1.02. What is the ratio of the Value added (current US$) of Belize in 1987 to that in 2006?
Make the answer very short. 0.35. What is the ratio of the Value added (current US$) in Ghana in 1987 to that in 2006?
Give a very brief answer. 0.43. What is the ratio of the Value added (current US$) of Iraq in 1987 to that in 2006?
Provide a succinct answer. 2.13. What is the ratio of the Value added (current US$) of Liberia in 1987 to that in 2006?
Make the answer very short. 0.96. What is the ratio of the Value added (current US$) in Belize in 1988 to that in 1989?
Provide a succinct answer. 0.9. What is the ratio of the Value added (current US$) of Iraq in 1988 to that in 1989?
Your response must be concise. 0.85. What is the ratio of the Value added (current US$) in Liberia in 1988 to that in 1989?
Provide a succinct answer. 1.3. What is the ratio of the Value added (current US$) in Belize in 1988 to that in 1990?
Offer a very short reply. 0.83. What is the ratio of the Value added (current US$) in Ghana in 1988 to that in 1990?
Provide a succinct answer. 0.98. What is the ratio of the Value added (current US$) of Iraq in 1988 to that in 1990?
Make the answer very short. 0.61. What is the ratio of the Value added (current US$) in Liberia in 1988 to that in 1990?
Make the answer very short. 1.89. What is the ratio of the Value added (current US$) in Belize in 1988 to that in 2004?
Your answer should be very brief. 0.39. What is the ratio of the Value added (current US$) in Ghana in 1988 to that in 2004?
Keep it short and to the point. 0.77. What is the ratio of the Value added (current US$) in Iraq in 1988 to that in 2004?
Provide a succinct answer. 3.59. What is the ratio of the Value added (current US$) of Liberia in 1988 to that in 2004?
Make the answer very short. 1.28. What is the ratio of the Value added (current US$) of Belize in 1988 to that in 2005?
Provide a succinct answer. 0.4. What is the ratio of the Value added (current US$) in Ghana in 1988 to that in 2005?
Provide a succinct answer. 0.64. What is the ratio of the Value added (current US$) of Iraq in 1988 to that in 2005?
Provide a succinct answer. 2.65. What is the ratio of the Value added (current US$) in Liberia in 1988 to that in 2005?
Your answer should be compact. 1.09. What is the ratio of the Value added (current US$) in Belize in 1988 to that in 2006?
Provide a short and direct response. 0.38. What is the ratio of the Value added (current US$) of Ghana in 1988 to that in 2006?
Provide a short and direct response. 0.44. What is the ratio of the Value added (current US$) of Iraq in 1988 to that in 2006?
Your answer should be very brief. 2.4. What is the ratio of the Value added (current US$) in Liberia in 1988 to that in 2006?
Offer a very short reply. 1.03. What is the ratio of the Value added (current US$) in Belize in 1989 to that in 1990?
Keep it short and to the point. 0.92. What is the ratio of the Value added (current US$) in Ghana in 1989 to that in 1990?
Keep it short and to the point. 0.97. What is the ratio of the Value added (current US$) in Iraq in 1989 to that in 1990?
Make the answer very short. 0.73. What is the ratio of the Value added (current US$) of Liberia in 1989 to that in 1990?
Make the answer very short. 1.46. What is the ratio of the Value added (current US$) in Belize in 1989 to that in 2004?
Offer a very short reply. 0.43. What is the ratio of the Value added (current US$) of Ghana in 1989 to that in 2004?
Provide a short and direct response. 0.76. What is the ratio of the Value added (current US$) of Iraq in 1989 to that in 2004?
Make the answer very short. 4.24. What is the ratio of the Value added (current US$) of Liberia in 1989 to that in 2004?
Provide a short and direct response. 0.99. What is the ratio of the Value added (current US$) in Belize in 1989 to that in 2005?
Your response must be concise. 0.44. What is the ratio of the Value added (current US$) in Ghana in 1989 to that in 2005?
Offer a very short reply. 0.64. What is the ratio of the Value added (current US$) of Iraq in 1989 to that in 2005?
Keep it short and to the point. 3.13. What is the ratio of the Value added (current US$) of Liberia in 1989 to that in 2005?
Ensure brevity in your answer.  0.84. What is the ratio of the Value added (current US$) of Belize in 1989 to that in 2006?
Offer a very short reply. 0.42. What is the ratio of the Value added (current US$) of Ghana in 1989 to that in 2006?
Make the answer very short. 0.44. What is the ratio of the Value added (current US$) in Iraq in 1989 to that in 2006?
Provide a short and direct response. 2.84. What is the ratio of the Value added (current US$) in Liberia in 1989 to that in 2006?
Offer a very short reply. 0.79. What is the ratio of the Value added (current US$) in Belize in 1990 to that in 2004?
Offer a terse response. 0.47. What is the ratio of the Value added (current US$) in Ghana in 1990 to that in 2004?
Your response must be concise. 0.78. What is the ratio of the Value added (current US$) in Iraq in 1990 to that in 2004?
Keep it short and to the point. 5.84. What is the ratio of the Value added (current US$) of Liberia in 1990 to that in 2004?
Provide a succinct answer. 0.68. What is the ratio of the Value added (current US$) of Belize in 1990 to that in 2005?
Offer a very short reply. 0.48. What is the ratio of the Value added (current US$) in Ghana in 1990 to that in 2005?
Make the answer very short. 0.66. What is the ratio of the Value added (current US$) in Iraq in 1990 to that in 2005?
Keep it short and to the point. 4.31. What is the ratio of the Value added (current US$) in Liberia in 1990 to that in 2005?
Your answer should be compact. 0.58. What is the ratio of the Value added (current US$) of Belize in 1990 to that in 2006?
Provide a short and direct response. 0.46. What is the ratio of the Value added (current US$) in Ghana in 1990 to that in 2006?
Offer a very short reply. 0.45. What is the ratio of the Value added (current US$) of Iraq in 1990 to that in 2006?
Your response must be concise. 3.91. What is the ratio of the Value added (current US$) in Liberia in 1990 to that in 2006?
Make the answer very short. 0.54. What is the ratio of the Value added (current US$) in Belize in 2004 to that in 2005?
Your response must be concise. 1.02. What is the ratio of the Value added (current US$) of Ghana in 2004 to that in 2005?
Ensure brevity in your answer.  0.84. What is the ratio of the Value added (current US$) of Iraq in 2004 to that in 2005?
Provide a succinct answer. 0.74. What is the ratio of the Value added (current US$) of Liberia in 2004 to that in 2005?
Keep it short and to the point. 0.85. What is the ratio of the Value added (current US$) of Belize in 2004 to that in 2006?
Your response must be concise. 0.98. What is the ratio of the Value added (current US$) in Ghana in 2004 to that in 2006?
Make the answer very short. 0.57. What is the ratio of the Value added (current US$) in Iraq in 2004 to that in 2006?
Offer a terse response. 0.67. What is the ratio of the Value added (current US$) of Liberia in 2004 to that in 2006?
Your answer should be very brief. 0.8. What is the ratio of the Value added (current US$) of Belize in 2005 to that in 2006?
Provide a succinct answer. 0.96. What is the ratio of the Value added (current US$) of Ghana in 2005 to that in 2006?
Offer a very short reply. 0.68. What is the ratio of the Value added (current US$) in Iraq in 2005 to that in 2006?
Ensure brevity in your answer.  0.91. What is the ratio of the Value added (current US$) in Liberia in 2005 to that in 2006?
Your response must be concise. 0.94. What is the difference between the highest and the second highest Value added (current US$) of Belize?
Offer a terse response. 3.29e+06. What is the difference between the highest and the second highest Value added (current US$) in Ghana?
Provide a succinct answer. 1.89e+09. What is the difference between the highest and the second highest Value added (current US$) in Iraq?
Your response must be concise. 4.08e+09. What is the difference between the highest and the second highest Value added (current US$) of Liberia?
Provide a short and direct response. 1.02e+07. What is the difference between the highest and the lowest Value added (current US$) in Belize?
Offer a terse response. 1.00e+08. What is the difference between the highest and the lowest Value added (current US$) in Ghana?
Ensure brevity in your answer.  3.34e+09. What is the difference between the highest and the lowest Value added (current US$) in Iraq?
Keep it short and to the point. 1.23e+1. What is the difference between the highest and the lowest Value added (current US$) of Liberia?
Keep it short and to the point. 1.87e+08. 